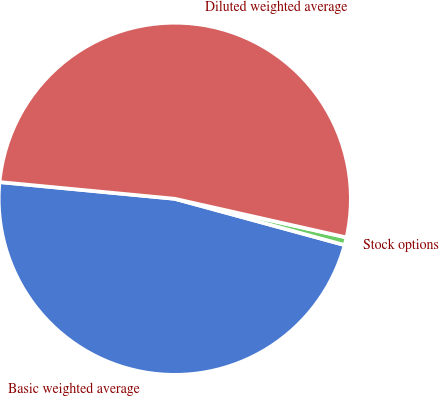<chart> <loc_0><loc_0><loc_500><loc_500><pie_chart><fcel>Basic weighted average<fcel>Stock options<fcel>Diluted weighted average<nl><fcel>47.28%<fcel>0.71%<fcel>52.01%<nl></chart> 